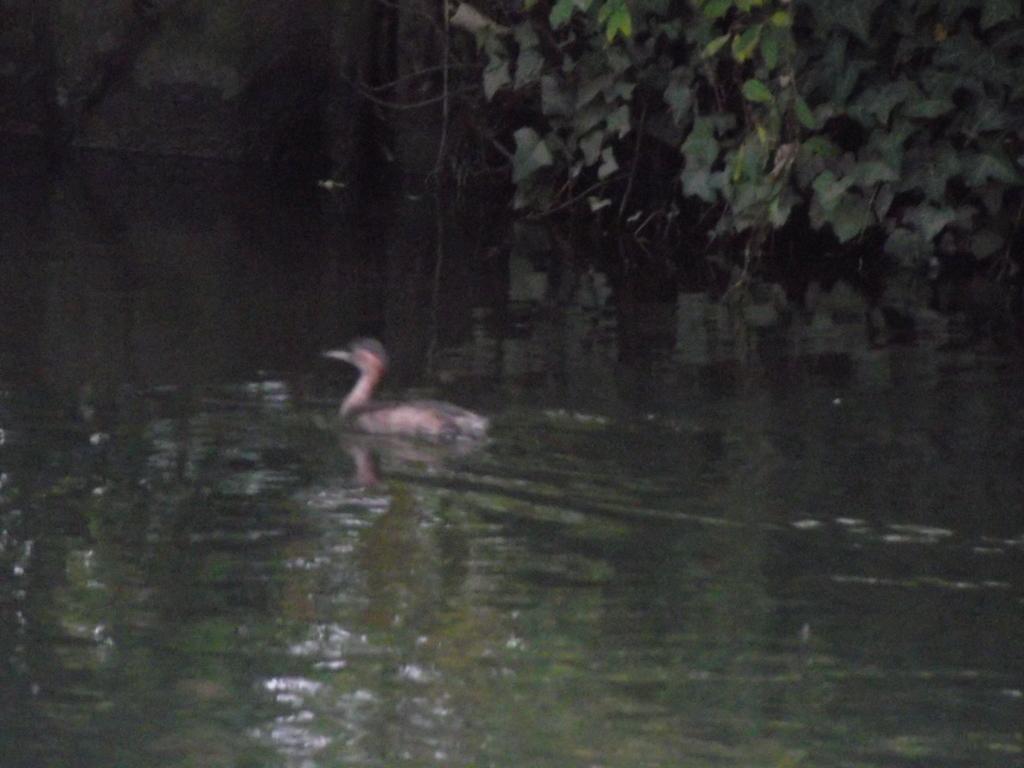Can you describe this image briefly? In this image there is a duck swimming on the water. In the top right there are leaves of a plant. 